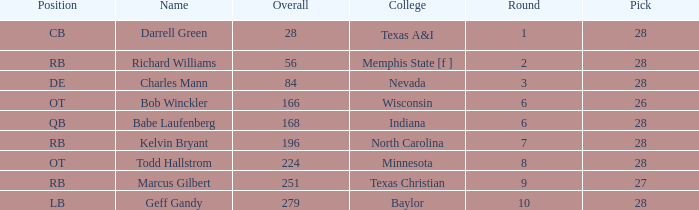What is the sum of the pick from texas a&i college with a round greater than 1? None. 